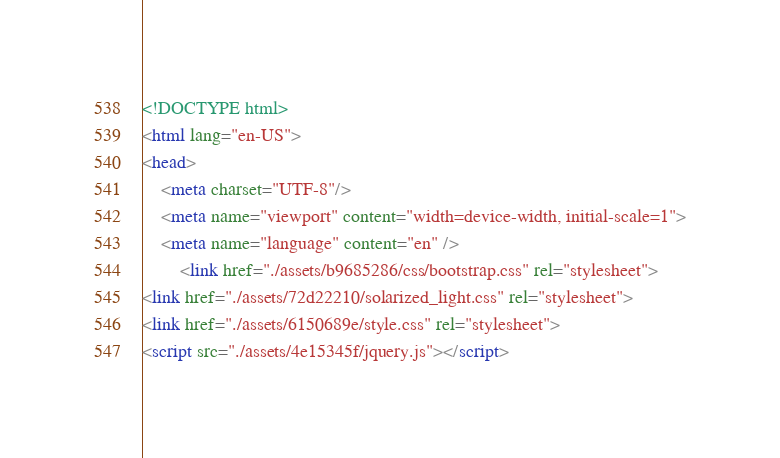<code> <loc_0><loc_0><loc_500><loc_500><_HTML_><!DOCTYPE html>
<html lang="en-US">
<head>
    <meta charset="UTF-8"/>
    <meta name="viewport" content="width=device-width, initial-scale=1">
    <meta name="language" content="en" />
        <link href="./assets/b9685286/css/bootstrap.css" rel="stylesheet">
<link href="./assets/72d22210/solarized_light.css" rel="stylesheet">
<link href="./assets/6150689e/style.css" rel="stylesheet">
<script src="./assets/4e15345f/jquery.js"></script></code> 